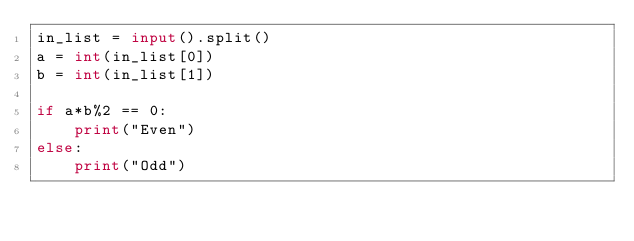<code> <loc_0><loc_0><loc_500><loc_500><_Python_>in_list = input().split()
a = int(in_list[0])
b = int(in_list[1])

if a*b%2 == 0:
    print("Even")
else:
    print("Odd")</code> 